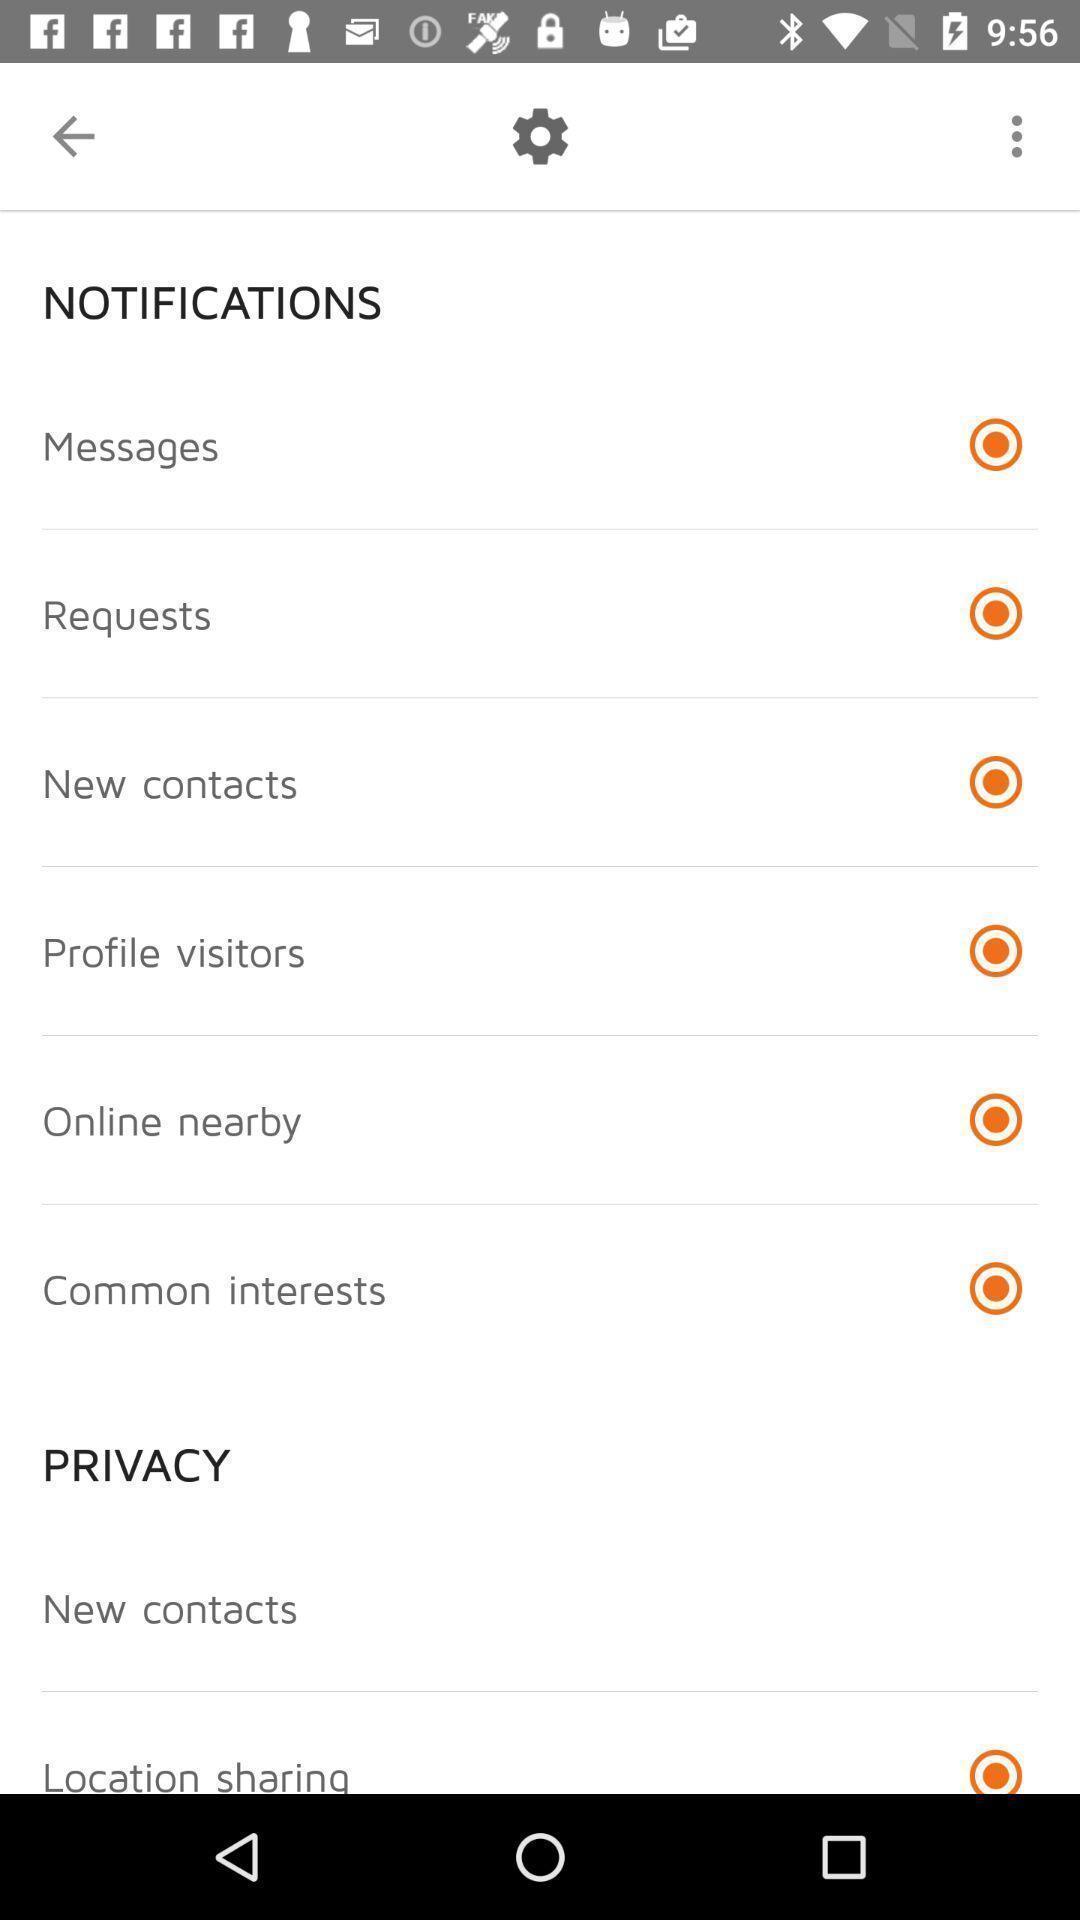Give me a summary of this screen capture. Settings page with various options to enable or disable. 